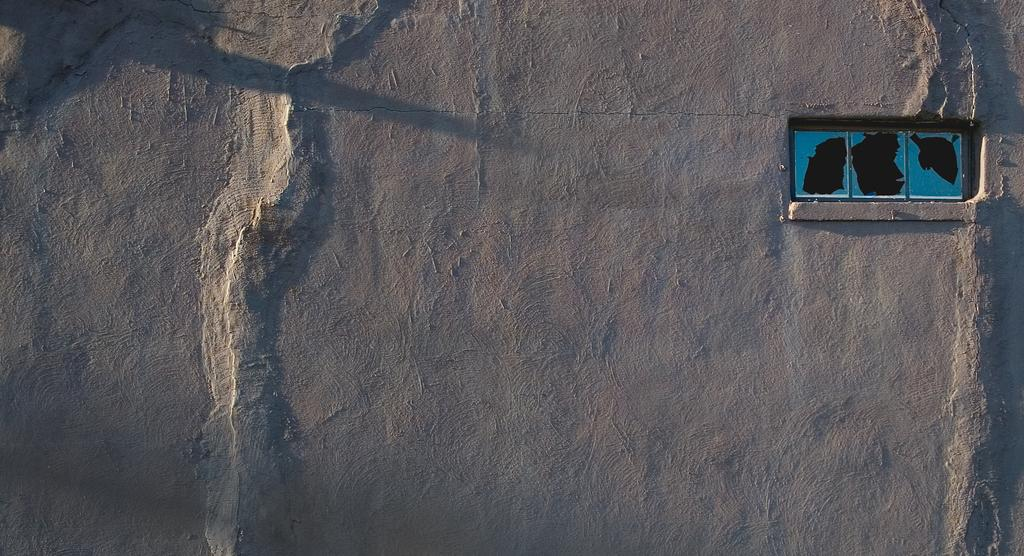What type of image is shown in the picture? The image appears to be a satellite image. What can be seen on the land in the image? There is an open area visible on the land in the image. What is the shape and location of the water in the image? There is a rectangle box on the right side of the image, and there is water visible within it. Where is the faucet located in the image? There is no faucet present in the image, as it is a satellite image showing land and water. Can you see any cabbage growing in the open area of the image? There is no cabbage visible in the image; it only shows land, water, and an open area. 